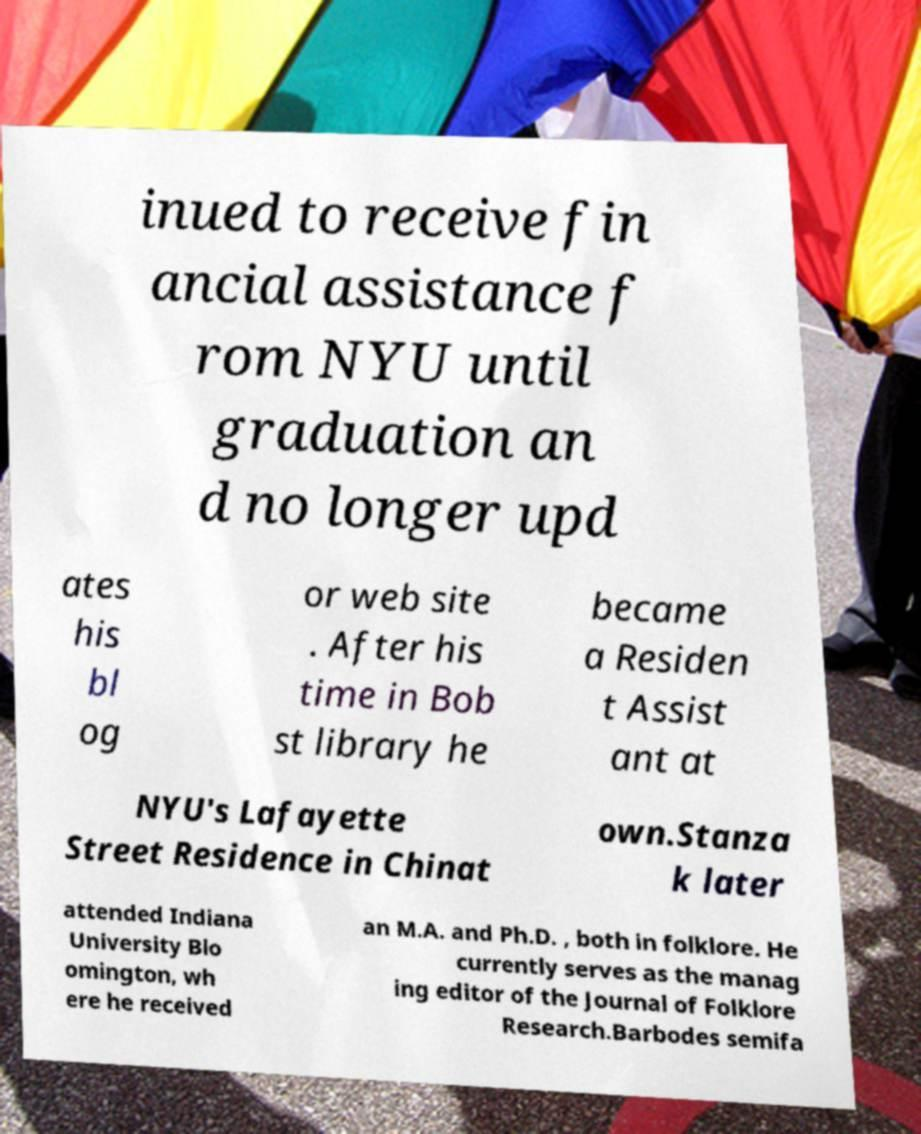For documentation purposes, I need the text within this image transcribed. Could you provide that? inued to receive fin ancial assistance f rom NYU until graduation an d no longer upd ates his bl og or web site . After his time in Bob st library he became a Residen t Assist ant at NYU's Lafayette Street Residence in Chinat own.Stanza k later attended Indiana University Blo omington, wh ere he received an M.A. and Ph.D. , both in folklore. He currently serves as the manag ing editor of the Journal of Folklore Research.Barbodes semifa 